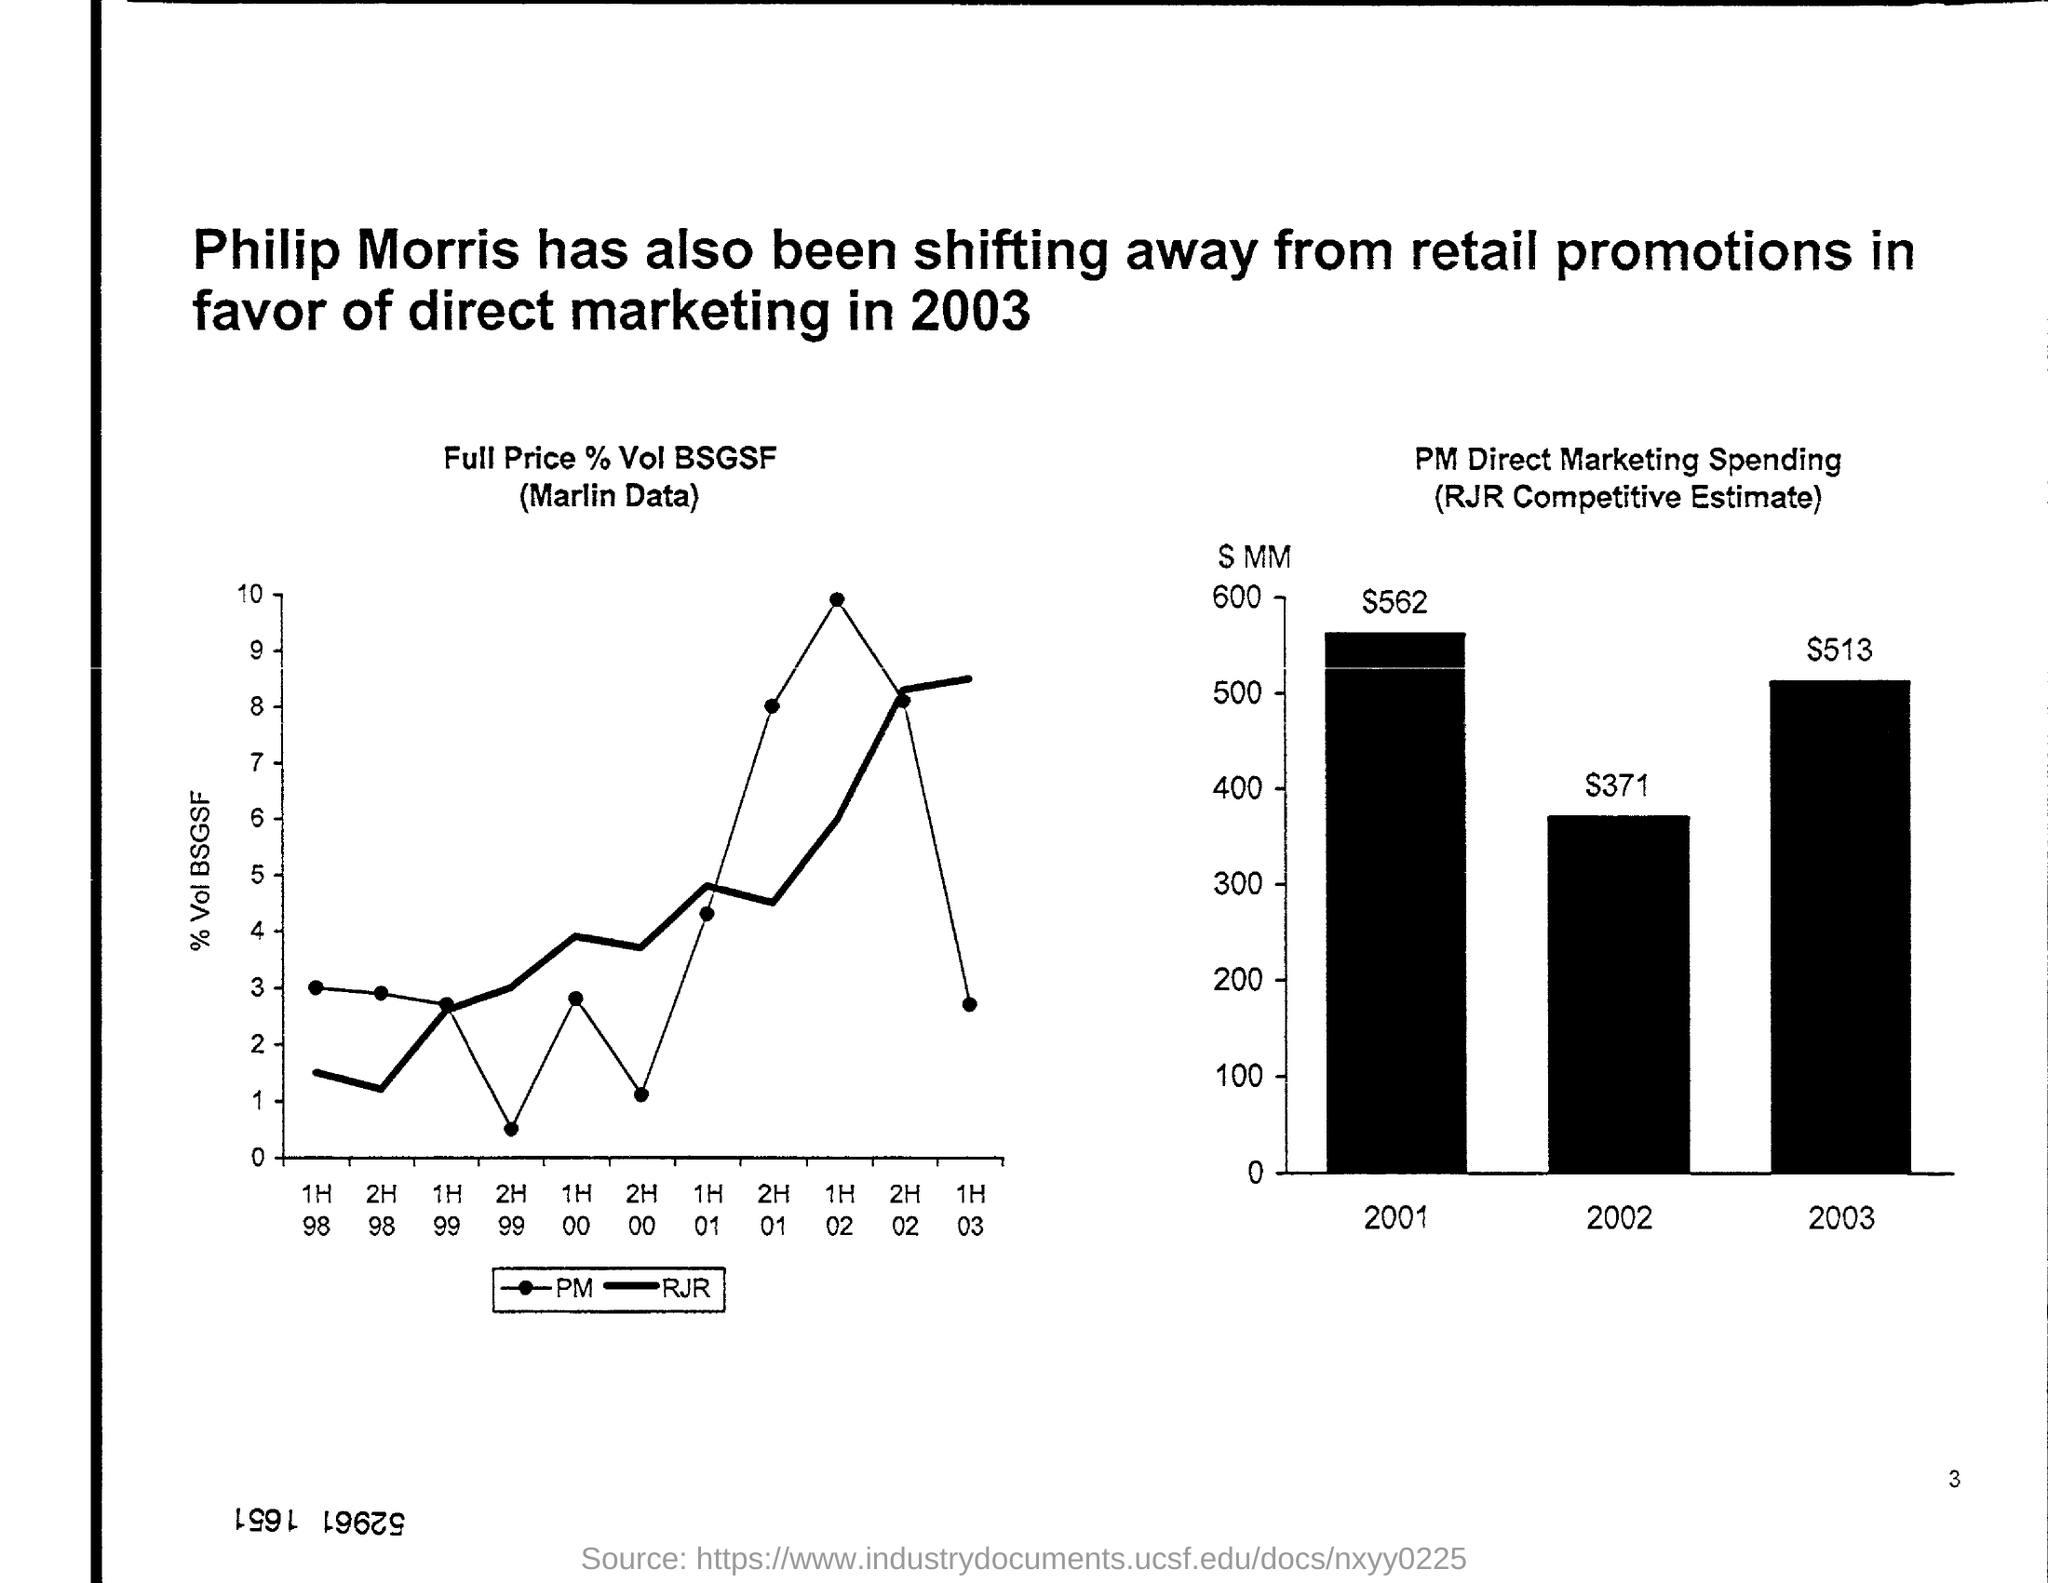What is the RJR Competitive Estimate in the year 2002?
Offer a very short reply. $371. In which year has Philip Morris been shifting away from retail promotions in favor of direct marketing?
Provide a succinct answer. 2003. What is the graph about?
Offer a terse response. Full Price % Vol BSGSF (Marlin Data). What is the bar chart title?
Your answer should be very brief. PM Direct Marketing Spending (RJR Competitive Estimate). 